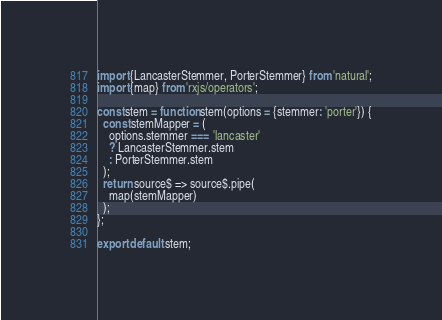<code> <loc_0><loc_0><loc_500><loc_500><_JavaScript_>import {LancasterStemmer, PorterStemmer} from 'natural';
import {map} from 'rxjs/operators';

const stem = function stem(options = {stemmer: 'porter'}) {
  const stemMapper = (
    options.stemmer === 'lancaster'
    ? LancasterStemmer.stem
    : PorterStemmer.stem
  );
  return source$ => source$.pipe(
    map(stemMapper)
  );
};

export default stem;
</code> 